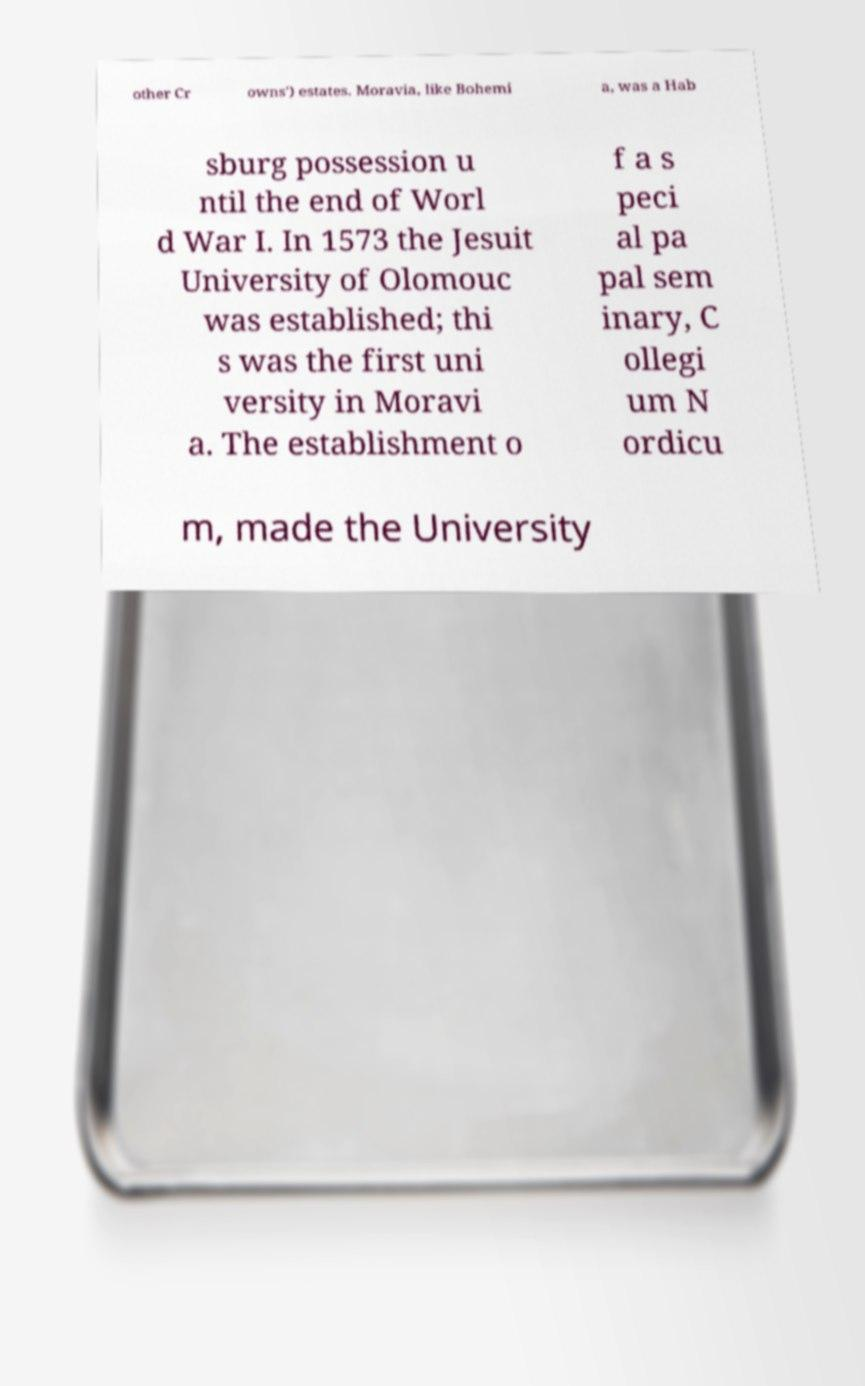I need the written content from this picture converted into text. Can you do that? other Cr owns') estates. Moravia, like Bohemi a, was a Hab sburg possession u ntil the end of Worl d War I. In 1573 the Jesuit University of Olomouc was established; thi s was the first uni versity in Moravi a. The establishment o f a s peci al pa pal sem inary, C ollegi um N ordicu m, made the University 